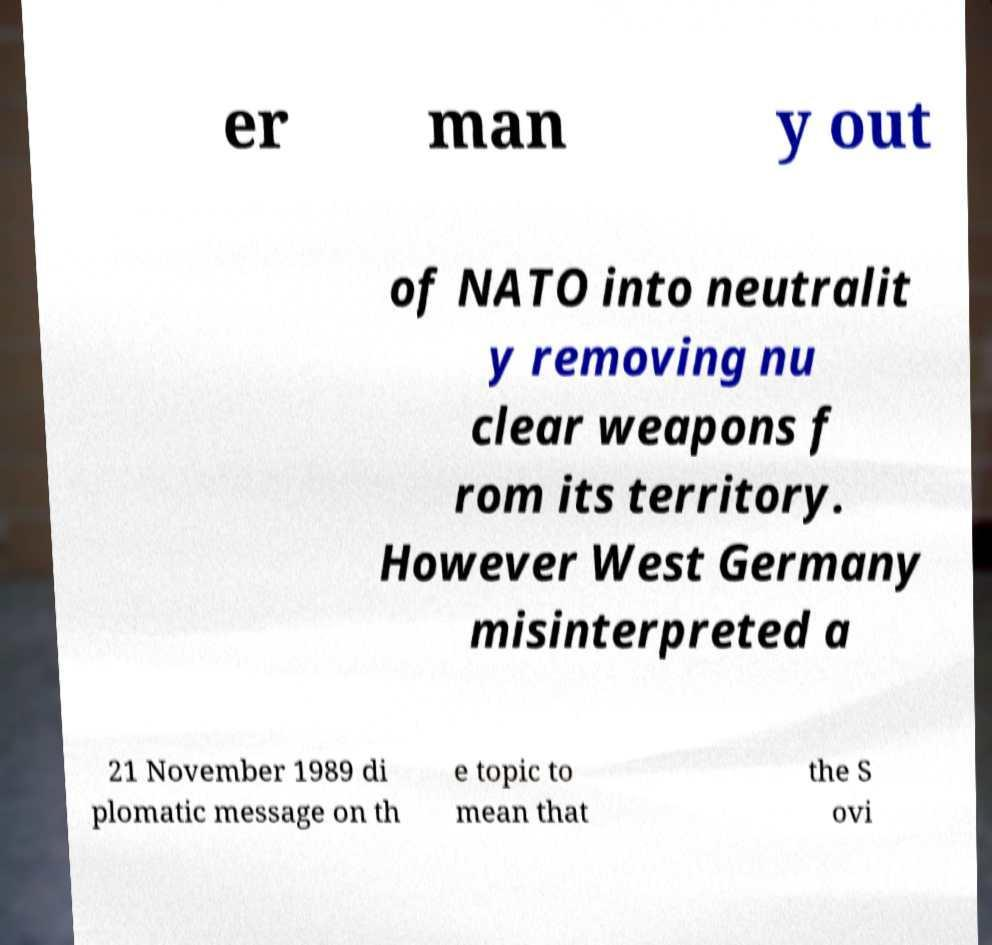Please identify and transcribe the text found in this image. er man y out of NATO into neutralit y removing nu clear weapons f rom its territory. However West Germany misinterpreted a 21 November 1989 di plomatic message on th e topic to mean that the S ovi 